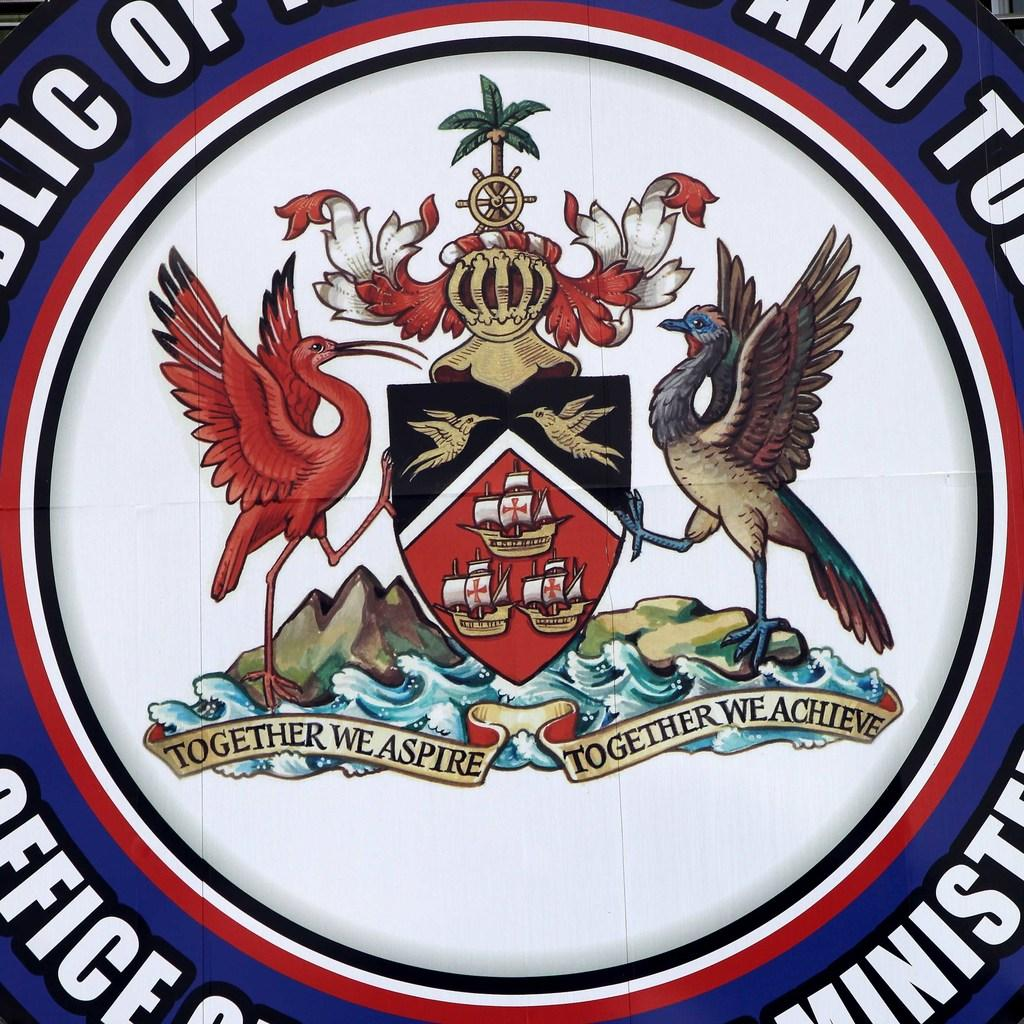What type of design is depicted in the image? The image appears to be an emblem. What images can be seen on the emblem? There are images of birds, boats, water, hills, and a tree on the emblem. Are there any words present on the emblem? Yes, there are words on the emblem. How many children are playing on the plane in the image? There is no plane or children present in the image; it features an emblem with various images, including birds, boats, water, hills, and a tree. 